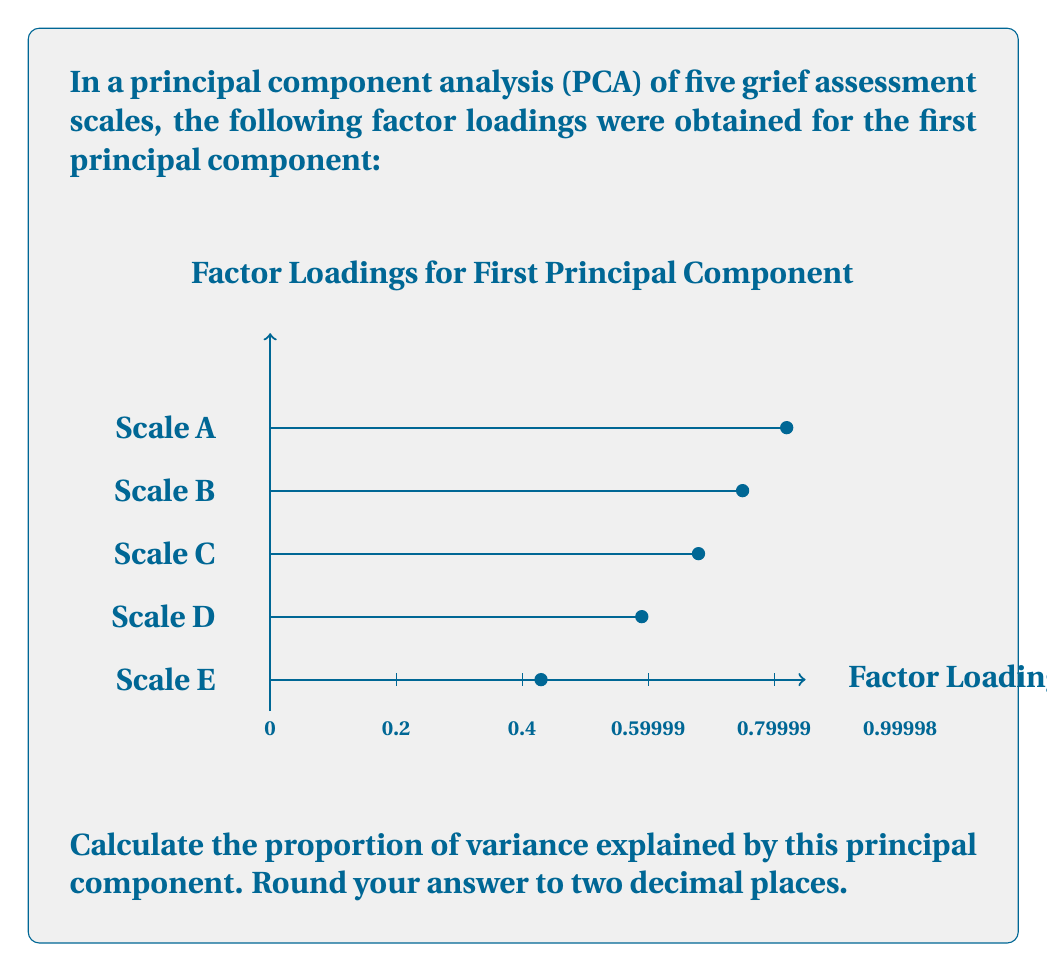Provide a solution to this math problem. To calculate the proportion of variance explained by a principal component in PCA, we follow these steps:

1) Square each factor loading:
   $0.82^2 = 0.6724$
   $0.75^2 = 0.5625$
   $0.68^2 = 0.4624$
   $0.59^2 = 0.3481$
   $0.43^2 = 0.1849$

2) Sum the squared factor loadings:
   $0.6724 + 0.5625 + 0.4624 + 0.3481 + 0.1849 = 2.2303$

3) Divide this sum by the number of variables (scales) to get the proportion of variance explained:
   $\frac{2.2303}{5} = 0.44606$

4) Round to two decimal places:
   $0.44606 \approx 0.45$

This means that the first principal component explains approximately 45% of the total variance in the five grief assessment scales.
Answer: 0.45 